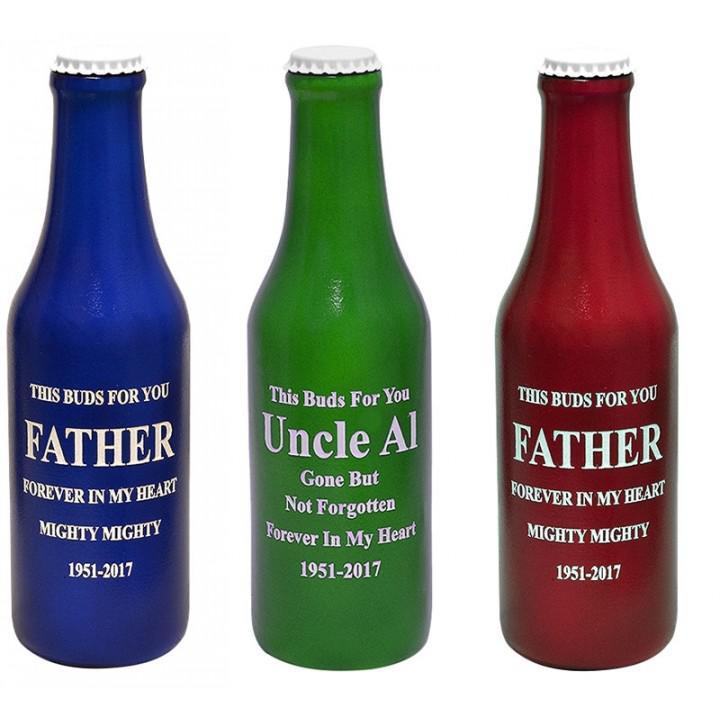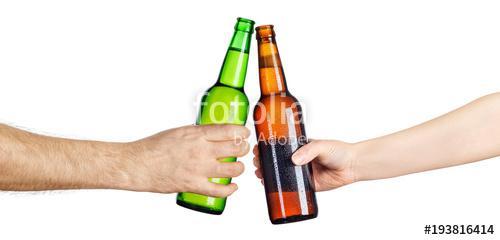The first image is the image on the left, the second image is the image on the right. Given the left and right images, does the statement "The right image shows two hands clinking two beer bottles together." hold true? Answer yes or no. Yes. The first image is the image on the left, the second image is the image on the right. Assess this claim about the two images: "A woman is smiling and looking to the left in the left image of the pair.". Correct or not? Answer yes or no. No. 